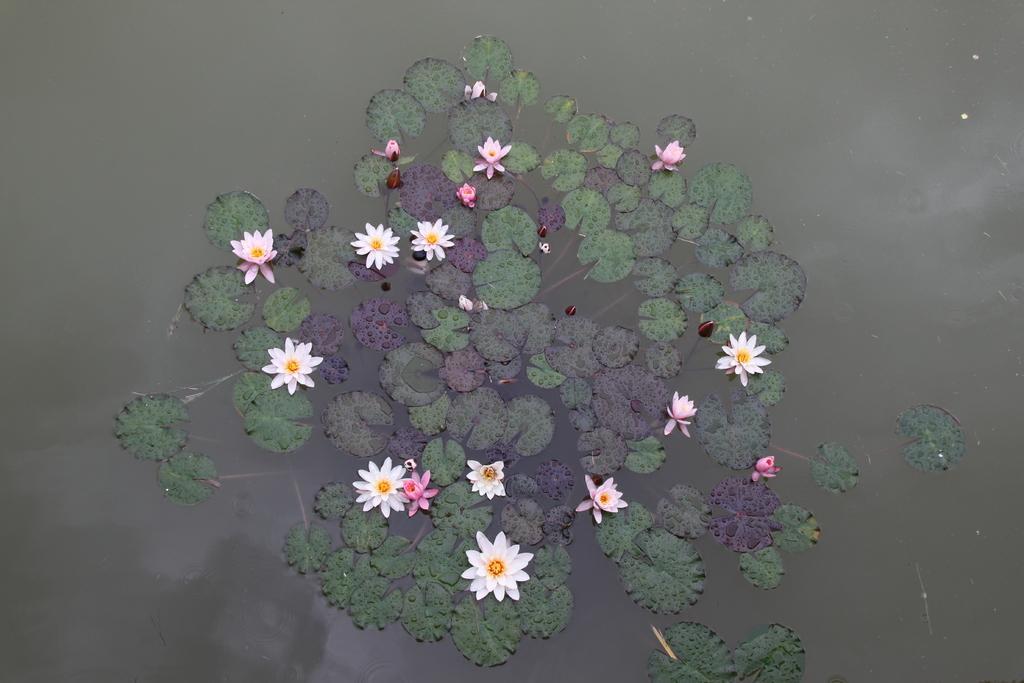Please provide a concise description of this image. This image is of a pond. There are lotus flowers and leaves in the center of the image. 